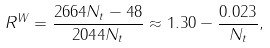<formula> <loc_0><loc_0><loc_500><loc_500>R ^ { W } = \frac { 2 6 6 4 N _ { t } - 4 8 } { 2 0 4 4 N _ { t } } \approx 1 . 3 0 - \frac { 0 . 0 2 3 } { N _ { t } } ,</formula> 